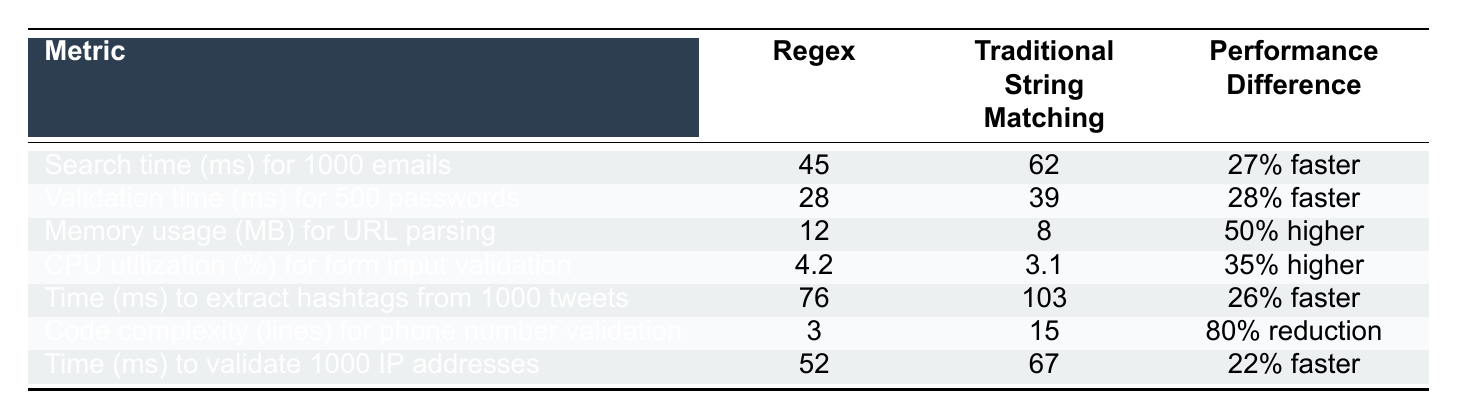What is the search time for 1000 emails using regex? The table shows that the search time for 1000 emails using regex is listed under the "Regex" column for that metric. It states 45 ms.
Answer: 45 ms What is the performance difference for validating 500 passwords between regex and traditional string matching? The performance difference is explicitly stated in the table under the "Performance Difference" column for the validation time of 500 passwords. It shows that regex is 28% faster.
Answer: 28% faster What is the memory usage for URL parsing using traditional string matching? The table lists the memory usage for URL parsing under the "Traditional String Matching" column, which indicates it uses 8 MB.
Answer: 8 MB Is regex faster than traditional string matching for extracting hashtags from 1000 tweets? By comparing the "Time (ms) to extract hashtags from 1000 tweets" row, regex has a time of 76 ms while traditional string matching is 103 ms, indicating that regex is indeed faster.
Answer: Yes What is the average CPU utilization for both regex and traditional string matching for form input validation? To find the average CPU utilization, sum the values for both methods: (4.2 + 3.1) = 7.3. Then divide by 2 to find the average: 7.3 / 2 = 3.65.
Answer: 3.65% Which metric shows a higher performance difference for regex compared to traditional string matching? By examining the performance differences across metrics, the "Code complexity (lines) for phone number validation" shows an 80% reduction, indicating the highest performance difference compared to the others.
Answer: Code complexity How much faster is regex in validating 1000 IP addresses compared to traditional string matching? The difference in time is provided in the table: regex takes 52 ms while traditional string matching takes 67 ms. To find how much faster, calculate the difference: 67 - 52 = 15 ms.
Answer: 15 ms Which approach uses more memory for URL parsing? The table indicates that regex uses 12 MB, while traditional string matching uses 8 MB. Thus, regex uses more memory.
Answer: Regex What is the total search time for both methods when searching 1000 emails and validating 500 passwords? The total search time is the sum of the search times for both metrics: 45 ms (regex) + 62 ms (traditional) + 28 ms (regex for passwords) + 39 ms (traditional for passwords) = 174 ms.
Answer: 174 ms Is it true that CPU utilization for regex is lower than that of traditional string matching? The table shows that regex has a CPU utilization of 4.2% compared to 3.1% for traditional string matching, meaning it is not true that regex has lower utilization.
Answer: No 